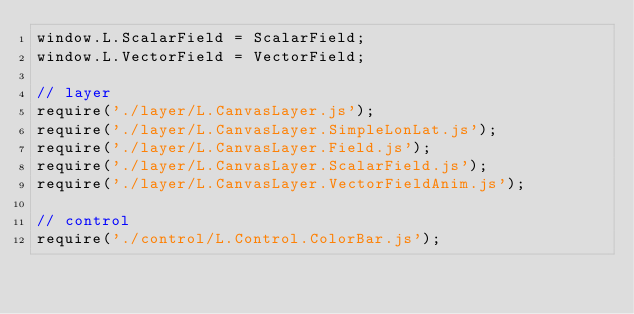<code> <loc_0><loc_0><loc_500><loc_500><_JavaScript_>window.L.ScalarField = ScalarField;
window.L.VectorField = VectorField;

// layer
require('./layer/L.CanvasLayer.js');
require('./layer/L.CanvasLayer.SimpleLonLat.js');
require('./layer/L.CanvasLayer.Field.js');
require('./layer/L.CanvasLayer.ScalarField.js');
require('./layer/L.CanvasLayer.VectorFieldAnim.js');

// control
require('./control/L.Control.ColorBar.js');
</code> 